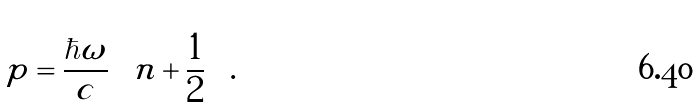<formula> <loc_0><loc_0><loc_500><loc_500>p = \frac { \hbar { \omega } } { c } \left ( n + \frac { 1 } { 2 } \right ) .</formula> 